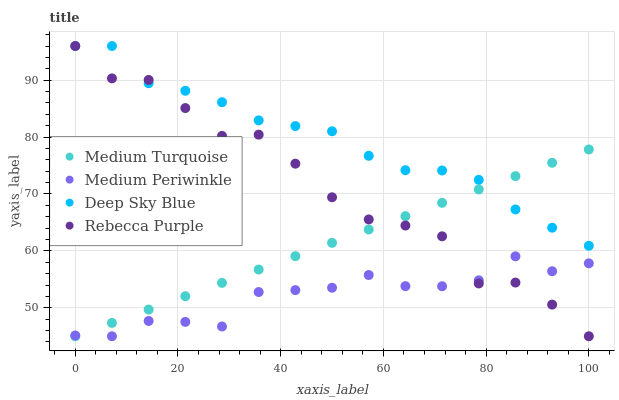Does Medium Periwinkle have the minimum area under the curve?
Answer yes or no. Yes. Does Deep Sky Blue have the maximum area under the curve?
Answer yes or no. Yes. Does Medium Turquoise have the minimum area under the curve?
Answer yes or no. No. Does Medium Turquoise have the maximum area under the curve?
Answer yes or no. No. Is Medium Turquoise the smoothest?
Answer yes or no. Yes. Is Rebecca Purple the roughest?
Answer yes or no. Yes. Is Deep Sky Blue the smoothest?
Answer yes or no. No. Is Deep Sky Blue the roughest?
Answer yes or no. No. Does Medium Periwinkle have the lowest value?
Answer yes or no. Yes. Does Deep Sky Blue have the lowest value?
Answer yes or no. No. Does Rebecca Purple have the highest value?
Answer yes or no. Yes. Does Medium Turquoise have the highest value?
Answer yes or no. No. Is Medium Periwinkle less than Deep Sky Blue?
Answer yes or no. Yes. Is Deep Sky Blue greater than Medium Periwinkle?
Answer yes or no. Yes. Does Medium Turquoise intersect Deep Sky Blue?
Answer yes or no. Yes. Is Medium Turquoise less than Deep Sky Blue?
Answer yes or no. No. Is Medium Turquoise greater than Deep Sky Blue?
Answer yes or no. No. Does Medium Periwinkle intersect Deep Sky Blue?
Answer yes or no. No. 